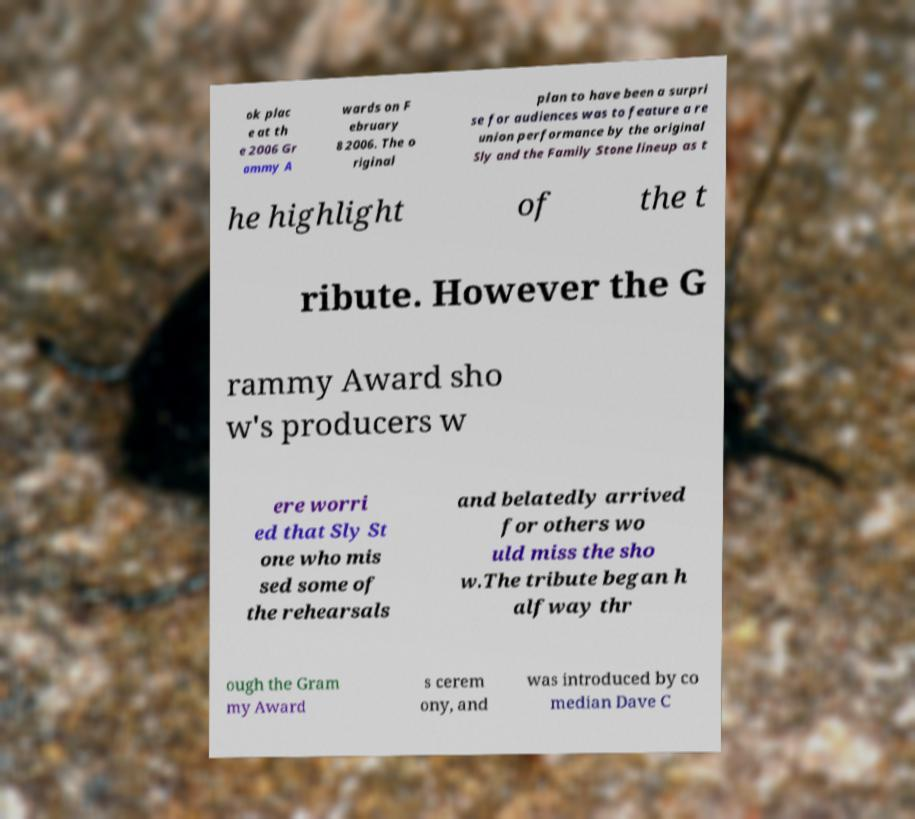Please read and relay the text visible in this image. What does it say? ok plac e at th e 2006 Gr ammy A wards on F ebruary 8 2006. The o riginal plan to have been a surpri se for audiences was to feature a re union performance by the original Sly and the Family Stone lineup as t he highlight of the t ribute. However the G rammy Award sho w's producers w ere worri ed that Sly St one who mis sed some of the rehearsals and belatedly arrived for others wo uld miss the sho w.The tribute began h alfway thr ough the Gram my Award s cerem ony, and was introduced by co median Dave C 